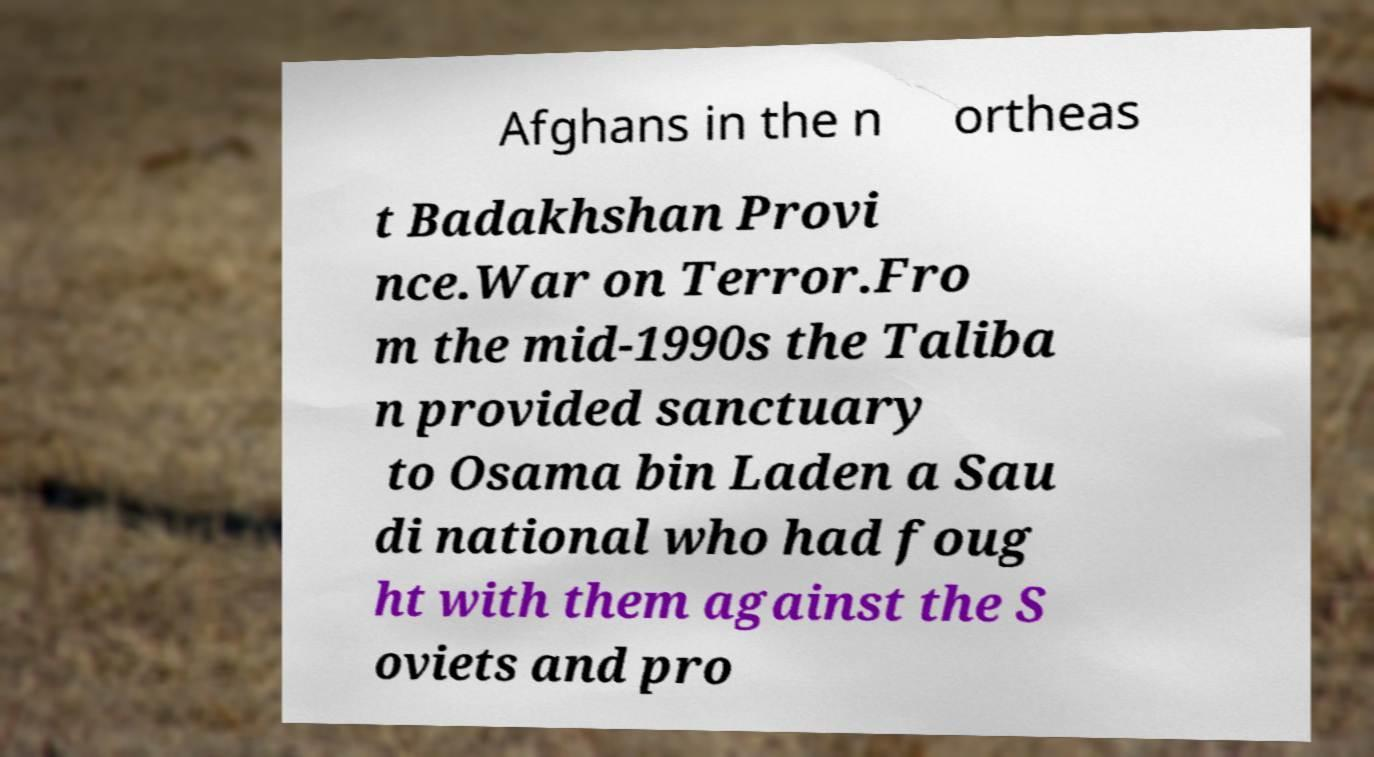Can you read and provide the text displayed in the image?This photo seems to have some interesting text. Can you extract and type it out for me? Afghans in the n ortheas t Badakhshan Provi nce.War on Terror.Fro m the mid-1990s the Taliba n provided sanctuary to Osama bin Laden a Sau di national who had foug ht with them against the S oviets and pro 